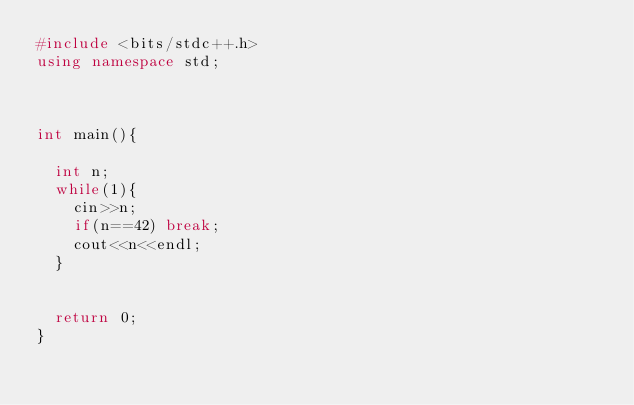<code> <loc_0><loc_0><loc_500><loc_500><_C++_>#include <bits/stdc++.h>
using namespace std;



int main(){
		
	int n;
	while(1){
		cin>>n;
		if(n==42) break;
		cout<<n<<endl;
	}
	
	
	return 0;
}
</code> 